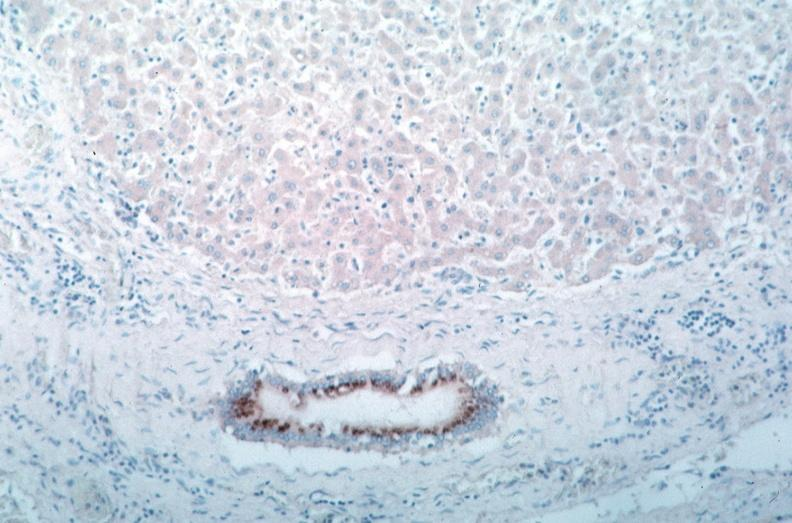s fibrinous peritonitis present?
Answer the question using a single word or phrase. No 